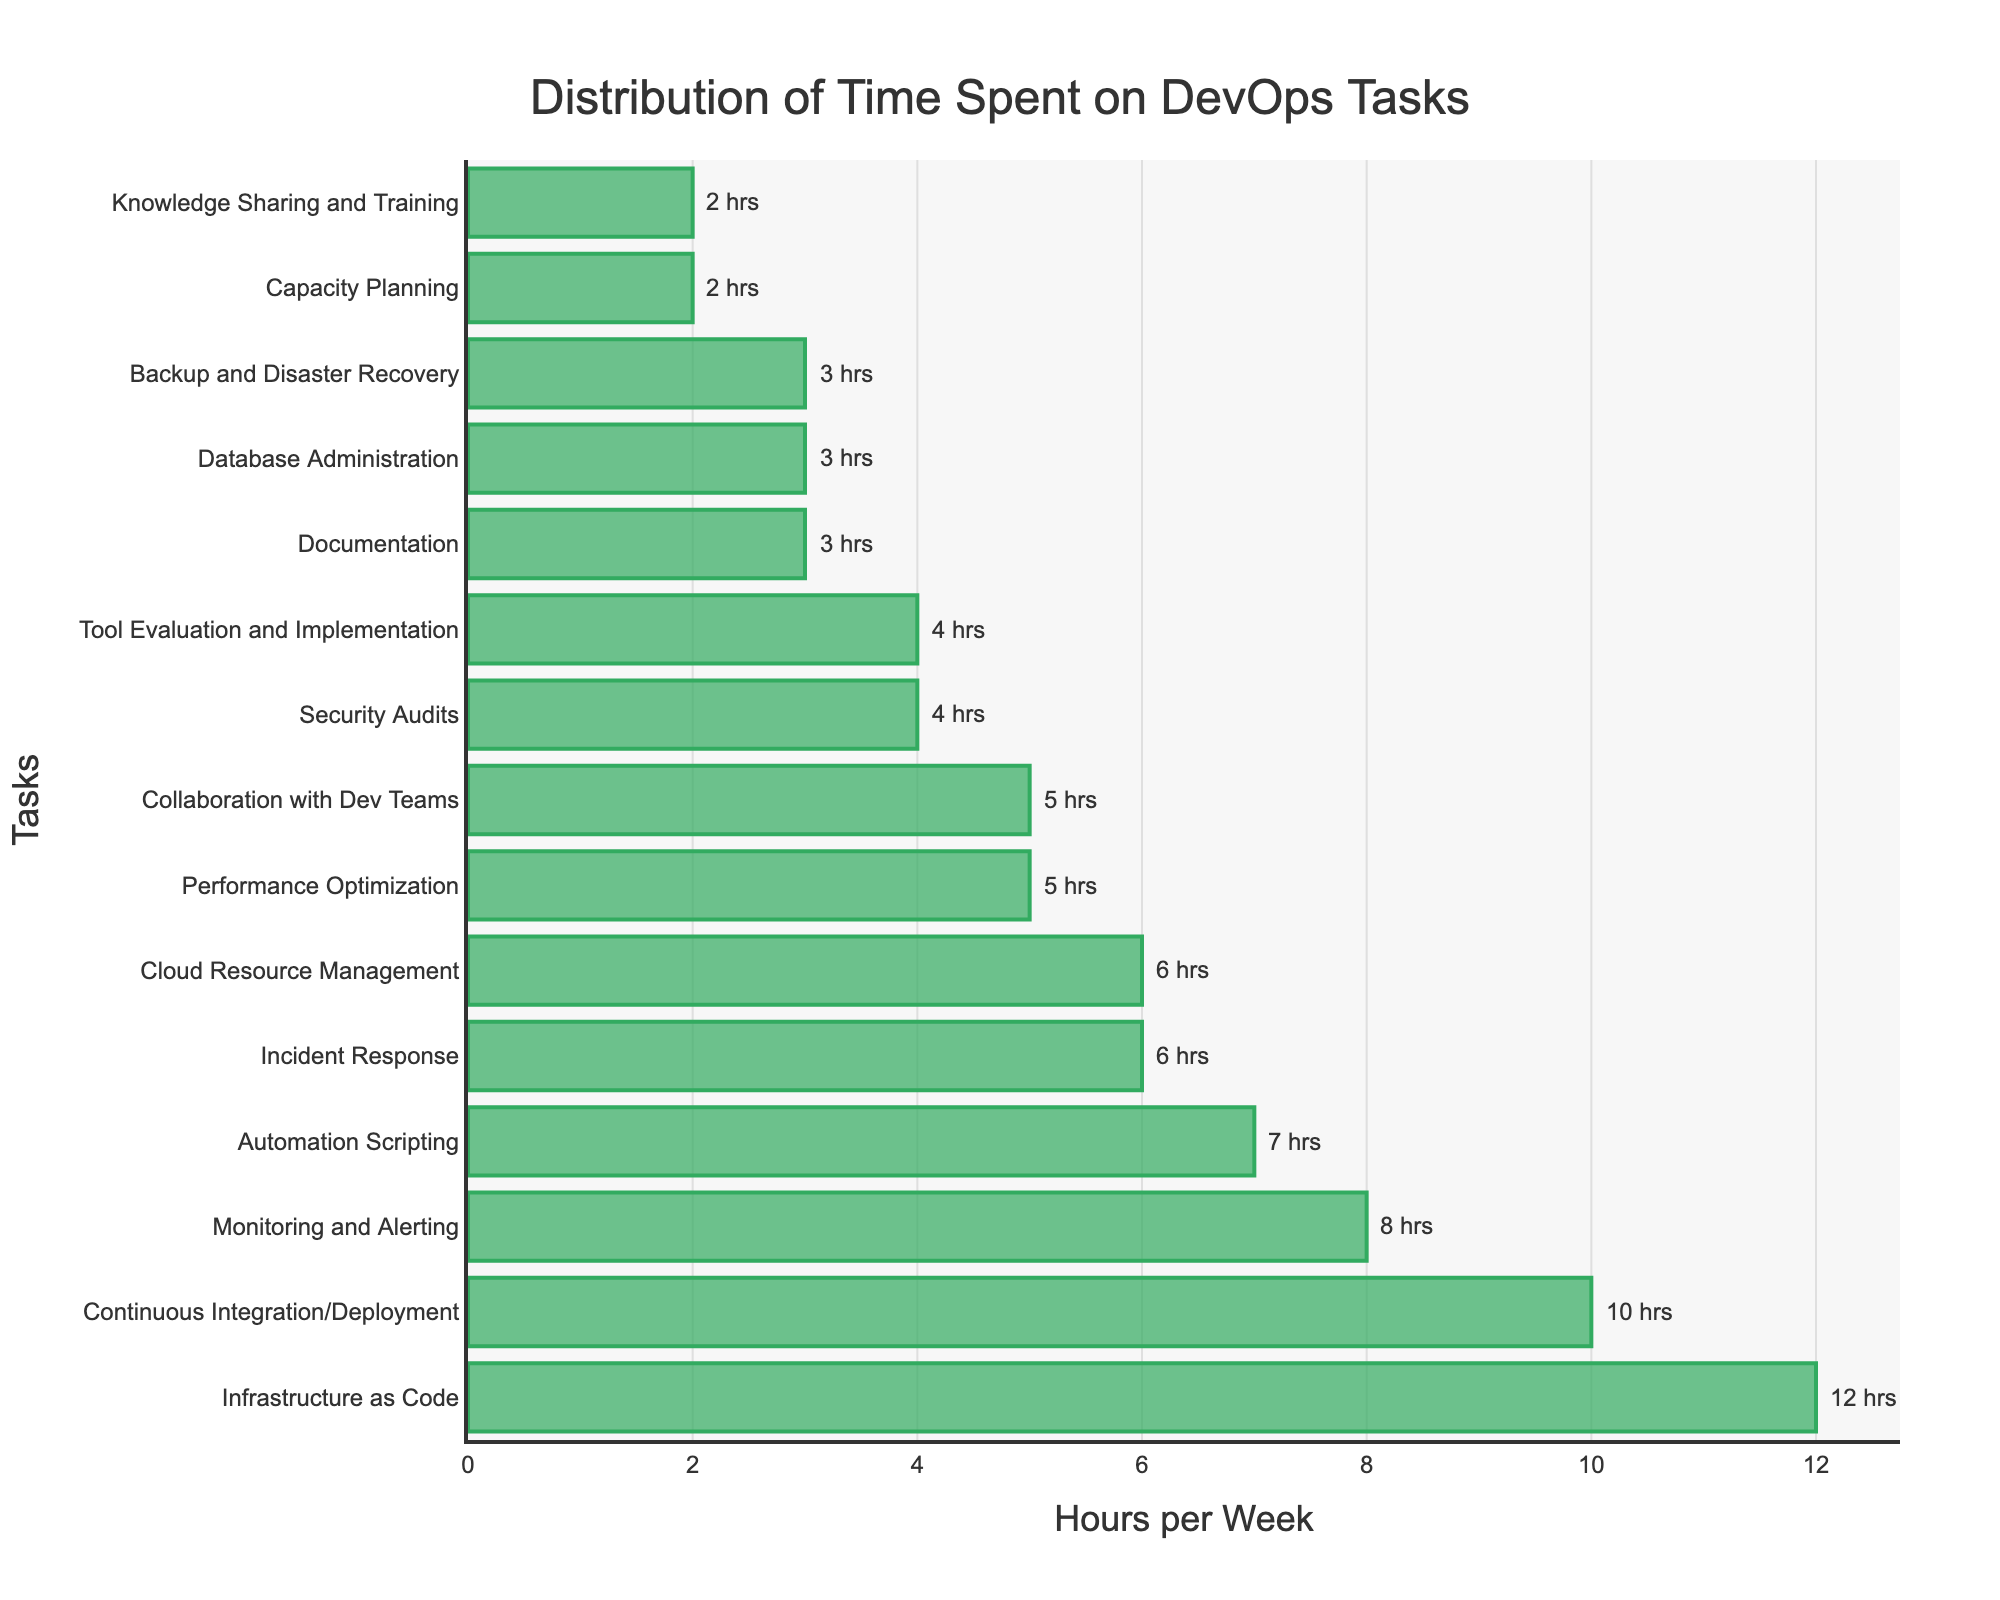Which task takes the most time in a typical work week? By looking at the figure, we can see that the task associated with the longest bar represents the task that takes the most time. The longest bar is "Infrastructure as Code," which is at the top of the chart.
Answer: Infrastructure as Code Which tasks take less time than "Continuous Integration/Deployment"? To determine which tasks take less time than "Continuous Integration/Deployment," we need to identify all tasks with bars shorter than "Continuous Integration/Deployment," which is 10 hours. These tasks include: Monitoring and Alerting, Incident Response, Performance Optimization, Security Audits, Automation Scripting, Cloud Resource Management, Collaboration with Dev Teams, Documentation, Capacity Planning, Tool Evaluation and Implementation, Database Administration, Backup and Disaster Recovery, and Knowledge Sharing and Training.
Answer: Monitoring and Alerting, Incident Response, Performance Optimization, Security Audits, Automation Scripting, Cloud Resource Management, Collaboration with Dev Teams, Documentation, Capacity Planning, Tool Evaluation and Implementation, Database Administration, Backup and Disaster Recovery, Knowledge Sharing and Training How many hours are spent on tasks related to security? We need to identify tasks related to security and sum their hours. Relevant tasks include "Security Audits" (4 hours) and "Backup and Disaster Recovery" (3 hours). The total is 4 + 3 = 7 hours.
Answer: 7 hours What is the difference in hours spent between "Incident Response" and "Cloud Resource Management"? To find the difference in hours, we need to subtract the hours spent on "Cloud Resource Management" from "Incident Response." "Incident Response" has 6 hours, and "Cloud Resource Management" has 6 hours, so the difference is 6 - 6 = 0 hours.
Answer: 0 hours What is the total time spent on "Collaboration with Dev Teams," "Documentation," and "Knowledge Sharing and Training"? To determine the total time, we sum the hours spent on each task. "Collaboration with Dev Teams" is 5 hours, "Documentation" is 3 hours, and "Knowledge Sharing and Training" is 2 hours. The total is 5 + 3 + 2 = 10 hours.
Answer: 10 hours Which task has the shortest bar in the figure? The task with the shortest bar corresponds to the one that takes the least time. In this case, "Capacity Planning" is the task with the shortest bar, indicating it takes 2 hours.
Answer: Capacity Planning 